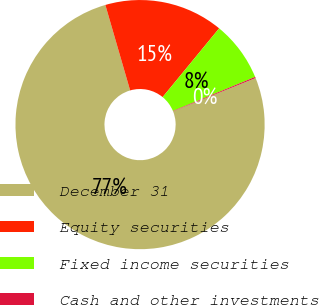<chart> <loc_0><loc_0><loc_500><loc_500><pie_chart><fcel>December 31<fcel>Equity securities<fcel>Fixed income securities<fcel>Cash and other investments<nl><fcel>76.61%<fcel>15.44%<fcel>7.8%<fcel>0.15%<nl></chart> 